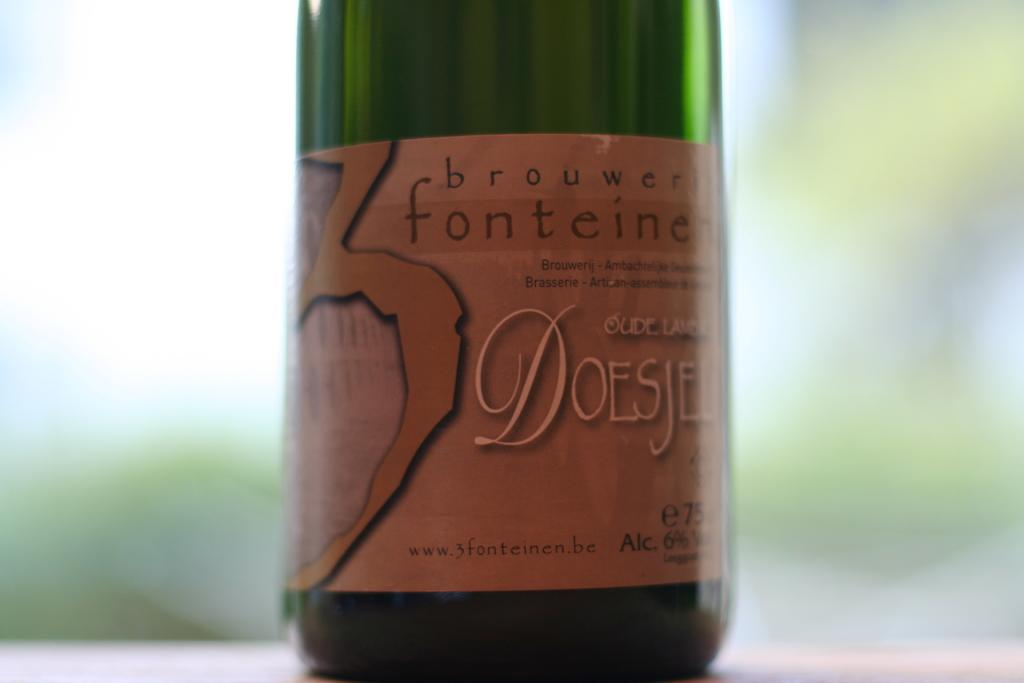Provide a one-sentence caption for the provided image. A green bottle of brouwer fonteine DOESJEL sitting on a table. 